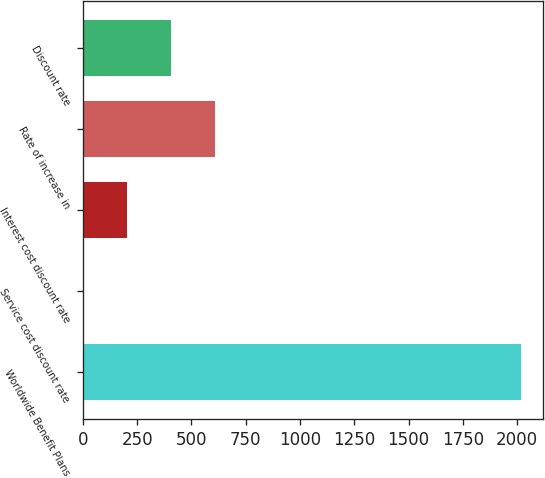<chart> <loc_0><loc_0><loc_500><loc_500><bar_chart><fcel>Worldwide Benefit Plans<fcel>Service cost discount rate<fcel>Interest cost discount rate<fcel>Rate of increase in<fcel>Discount rate<nl><fcel>2018<fcel>3.2<fcel>204.68<fcel>607.64<fcel>406.16<nl></chart> 